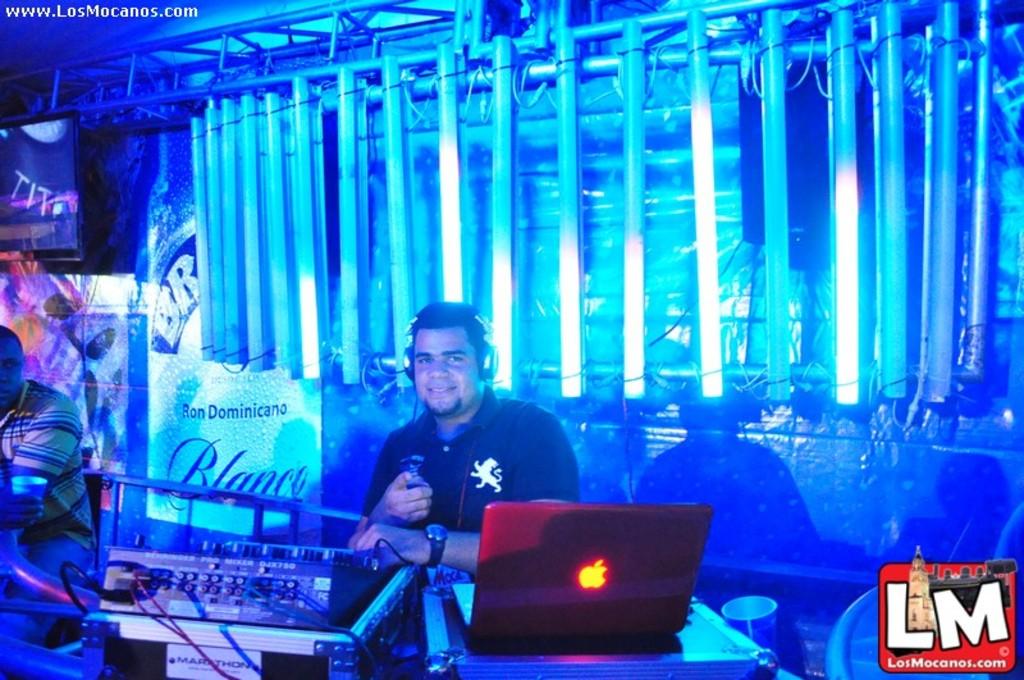What brand is the computer ?
Provide a short and direct response. Apple. What two big letters are in the bottom right corner?
Ensure brevity in your answer.  Lm. 